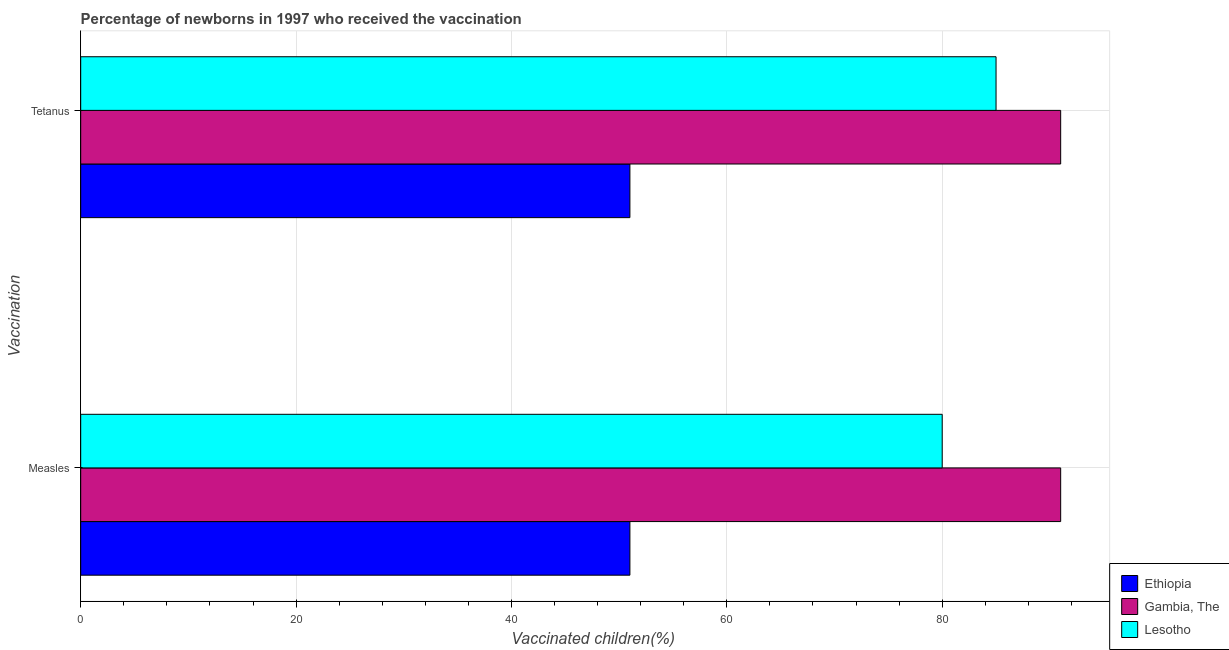How many different coloured bars are there?
Your answer should be very brief. 3. How many groups of bars are there?
Provide a succinct answer. 2. Are the number of bars per tick equal to the number of legend labels?
Offer a terse response. Yes. How many bars are there on the 2nd tick from the top?
Offer a terse response. 3. How many bars are there on the 2nd tick from the bottom?
Make the answer very short. 3. What is the label of the 1st group of bars from the top?
Offer a very short reply. Tetanus. What is the percentage of newborns who received vaccination for tetanus in Gambia, The?
Make the answer very short. 91. Across all countries, what is the maximum percentage of newborns who received vaccination for measles?
Your response must be concise. 91. Across all countries, what is the minimum percentage of newborns who received vaccination for tetanus?
Offer a very short reply. 51. In which country was the percentage of newborns who received vaccination for measles maximum?
Provide a succinct answer. Gambia, The. In which country was the percentage of newborns who received vaccination for measles minimum?
Keep it short and to the point. Ethiopia. What is the total percentage of newborns who received vaccination for measles in the graph?
Offer a terse response. 222. What is the difference between the percentage of newborns who received vaccination for tetanus in Ethiopia and that in Gambia, The?
Offer a very short reply. -40. What is the difference between the percentage of newborns who received vaccination for measles in Ethiopia and the percentage of newborns who received vaccination for tetanus in Lesotho?
Your response must be concise. -34. What is the average percentage of newborns who received vaccination for tetanus per country?
Offer a terse response. 75.67. What is the difference between the percentage of newborns who received vaccination for measles and percentage of newborns who received vaccination for tetanus in Gambia, The?
Ensure brevity in your answer.  0. What is the ratio of the percentage of newborns who received vaccination for tetanus in Lesotho to that in Gambia, The?
Your answer should be very brief. 0.93. In how many countries, is the percentage of newborns who received vaccination for measles greater than the average percentage of newborns who received vaccination for measles taken over all countries?
Your answer should be compact. 2. What does the 1st bar from the top in Measles represents?
Give a very brief answer. Lesotho. What does the 3rd bar from the bottom in Measles represents?
Your answer should be very brief. Lesotho. How many bars are there?
Give a very brief answer. 6. What is the difference between two consecutive major ticks on the X-axis?
Provide a succinct answer. 20. Are the values on the major ticks of X-axis written in scientific E-notation?
Give a very brief answer. No. Does the graph contain any zero values?
Keep it short and to the point. No. Does the graph contain grids?
Offer a very short reply. Yes. Where does the legend appear in the graph?
Offer a very short reply. Bottom right. How are the legend labels stacked?
Ensure brevity in your answer.  Vertical. What is the title of the graph?
Offer a terse response. Percentage of newborns in 1997 who received the vaccination. Does "Ukraine" appear as one of the legend labels in the graph?
Offer a very short reply. No. What is the label or title of the X-axis?
Give a very brief answer. Vaccinated children(%)
. What is the label or title of the Y-axis?
Ensure brevity in your answer.  Vaccination. What is the Vaccinated children(%)
 of Gambia, The in Measles?
Keep it short and to the point. 91. What is the Vaccinated children(%)
 of Lesotho in Measles?
Offer a terse response. 80. What is the Vaccinated children(%)
 of Gambia, The in Tetanus?
Your answer should be very brief. 91. Across all Vaccination, what is the maximum Vaccinated children(%)
 of Ethiopia?
Give a very brief answer. 51. Across all Vaccination, what is the maximum Vaccinated children(%)
 in Gambia, The?
Offer a very short reply. 91. Across all Vaccination, what is the minimum Vaccinated children(%)
 of Gambia, The?
Your answer should be very brief. 91. Across all Vaccination, what is the minimum Vaccinated children(%)
 in Lesotho?
Your response must be concise. 80. What is the total Vaccinated children(%)
 of Ethiopia in the graph?
Your response must be concise. 102. What is the total Vaccinated children(%)
 in Gambia, The in the graph?
Provide a short and direct response. 182. What is the total Vaccinated children(%)
 of Lesotho in the graph?
Make the answer very short. 165. What is the difference between the Vaccinated children(%)
 of Gambia, The in Measles and that in Tetanus?
Offer a terse response. 0. What is the difference between the Vaccinated children(%)
 of Ethiopia in Measles and the Vaccinated children(%)
 of Gambia, The in Tetanus?
Give a very brief answer. -40. What is the difference between the Vaccinated children(%)
 in Ethiopia in Measles and the Vaccinated children(%)
 in Lesotho in Tetanus?
Make the answer very short. -34. What is the difference between the Vaccinated children(%)
 in Gambia, The in Measles and the Vaccinated children(%)
 in Lesotho in Tetanus?
Keep it short and to the point. 6. What is the average Vaccinated children(%)
 in Gambia, The per Vaccination?
Your response must be concise. 91. What is the average Vaccinated children(%)
 in Lesotho per Vaccination?
Provide a succinct answer. 82.5. What is the difference between the Vaccinated children(%)
 of Ethiopia and Vaccinated children(%)
 of Lesotho in Measles?
Give a very brief answer. -29. What is the difference between the Vaccinated children(%)
 of Gambia, The and Vaccinated children(%)
 of Lesotho in Measles?
Make the answer very short. 11. What is the difference between the Vaccinated children(%)
 of Ethiopia and Vaccinated children(%)
 of Gambia, The in Tetanus?
Your response must be concise. -40. What is the difference between the Vaccinated children(%)
 of Ethiopia and Vaccinated children(%)
 of Lesotho in Tetanus?
Keep it short and to the point. -34. What is the difference between the Vaccinated children(%)
 of Gambia, The and Vaccinated children(%)
 of Lesotho in Tetanus?
Keep it short and to the point. 6. What is the ratio of the Vaccinated children(%)
 of Ethiopia in Measles to that in Tetanus?
Your answer should be very brief. 1. What is the ratio of the Vaccinated children(%)
 of Gambia, The in Measles to that in Tetanus?
Provide a short and direct response. 1. What is the ratio of the Vaccinated children(%)
 in Lesotho in Measles to that in Tetanus?
Give a very brief answer. 0.94. What is the difference between the highest and the second highest Vaccinated children(%)
 of Ethiopia?
Your answer should be compact. 0. What is the difference between the highest and the second highest Vaccinated children(%)
 of Gambia, The?
Make the answer very short. 0. What is the difference between the highest and the second highest Vaccinated children(%)
 of Lesotho?
Offer a very short reply. 5. What is the difference between the highest and the lowest Vaccinated children(%)
 in Gambia, The?
Give a very brief answer. 0. What is the difference between the highest and the lowest Vaccinated children(%)
 in Lesotho?
Keep it short and to the point. 5. 